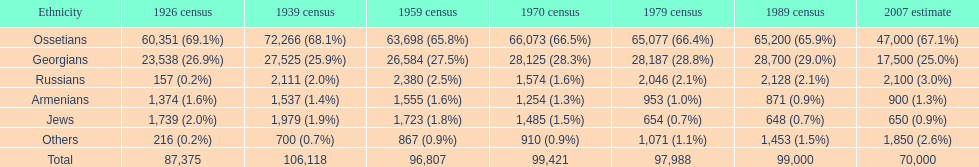What ethnicity is at the top? Ossetians. 